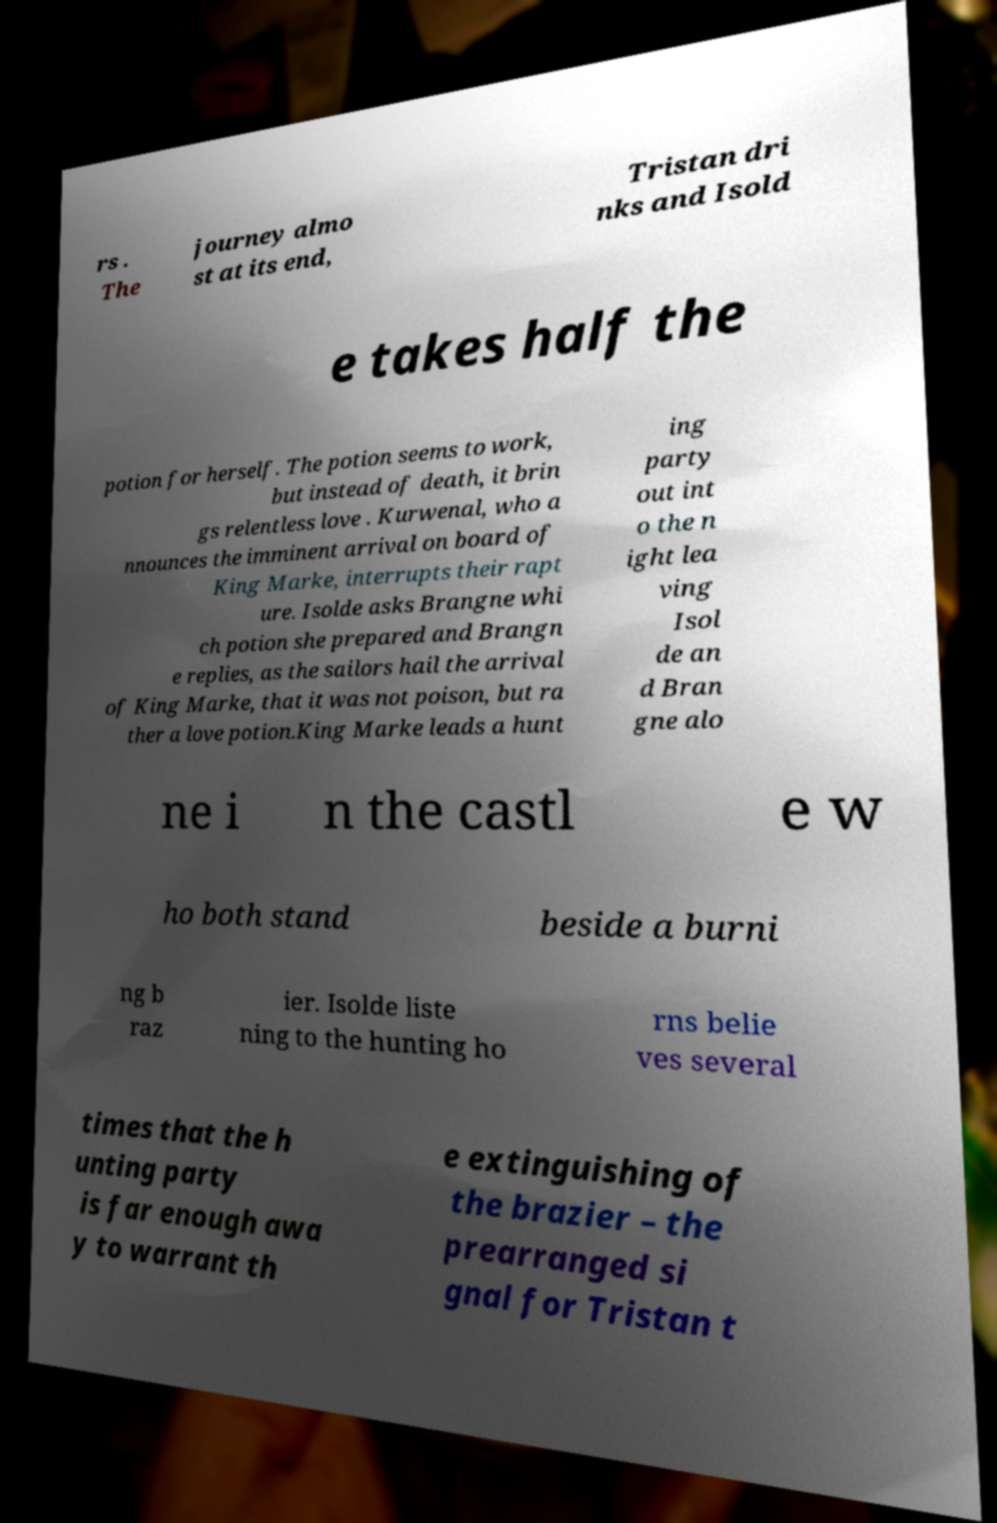Please read and relay the text visible in this image. What does it say? rs . The journey almo st at its end, Tristan dri nks and Isold e takes half the potion for herself. The potion seems to work, but instead of death, it brin gs relentless love . Kurwenal, who a nnounces the imminent arrival on board of King Marke, interrupts their rapt ure. Isolde asks Brangne whi ch potion she prepared and Brangn e replies, as the sailors hail the arrival of King Marke, that it was not poison, but ra ther a love potion.King Marke leads a hunt ing party out int o the n ight lea ving Isol de an d Bran gne alo ne i n the castl e w ho both stand beside a burni ng b raz ier. Isolde liste ning to the hunting ho rns belie ves several times that the h unting party is far enough awa y to warrant th e extinguishing of the brazier – the prearranged si gnal for Tristan t 